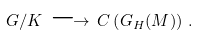<formula> <loc_0><loc_0><loc_500><loc_500>G / K \, \longrightarrow \, C \left ( G _ { H } ( M ) \right ) \, .</formula> 